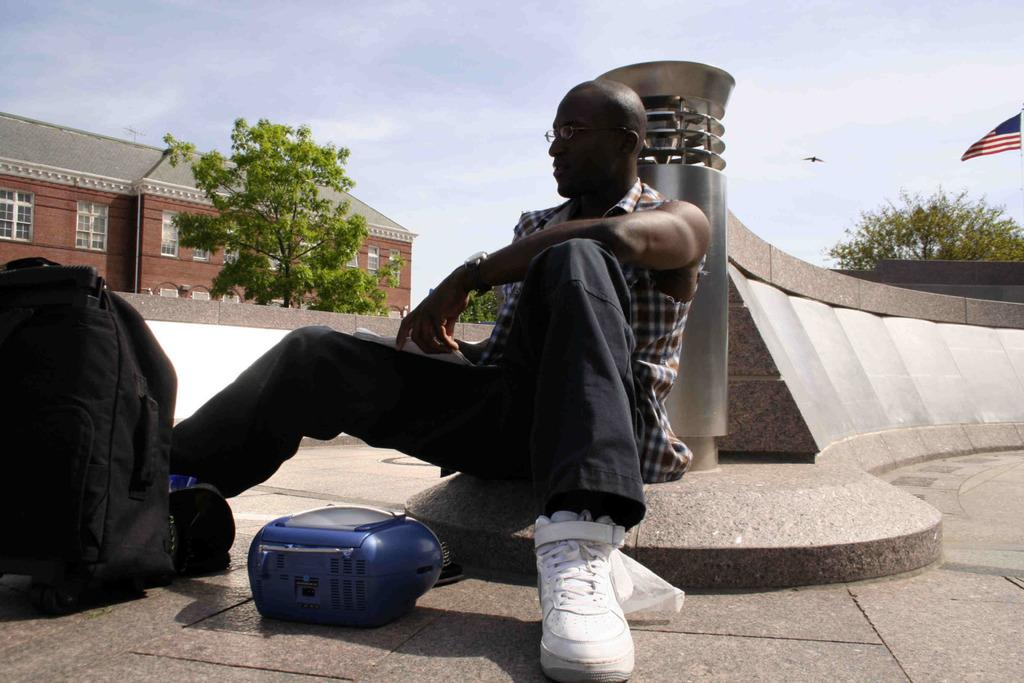What is the person in the image doing? The person is sitting on the floor in the image. What is located next to the person? There is a bag next to the person. What can be seen in the background of the image? There is a building and trees in the background of the image. What is the additional feature visible in the image? There is a flag visible in the image. What type of drink is being served at the coast in the image? There is no coast or drink present in the image. Is there any indication of a war or conflict in the image? No, there is no indication of a war or conflict in the image. 